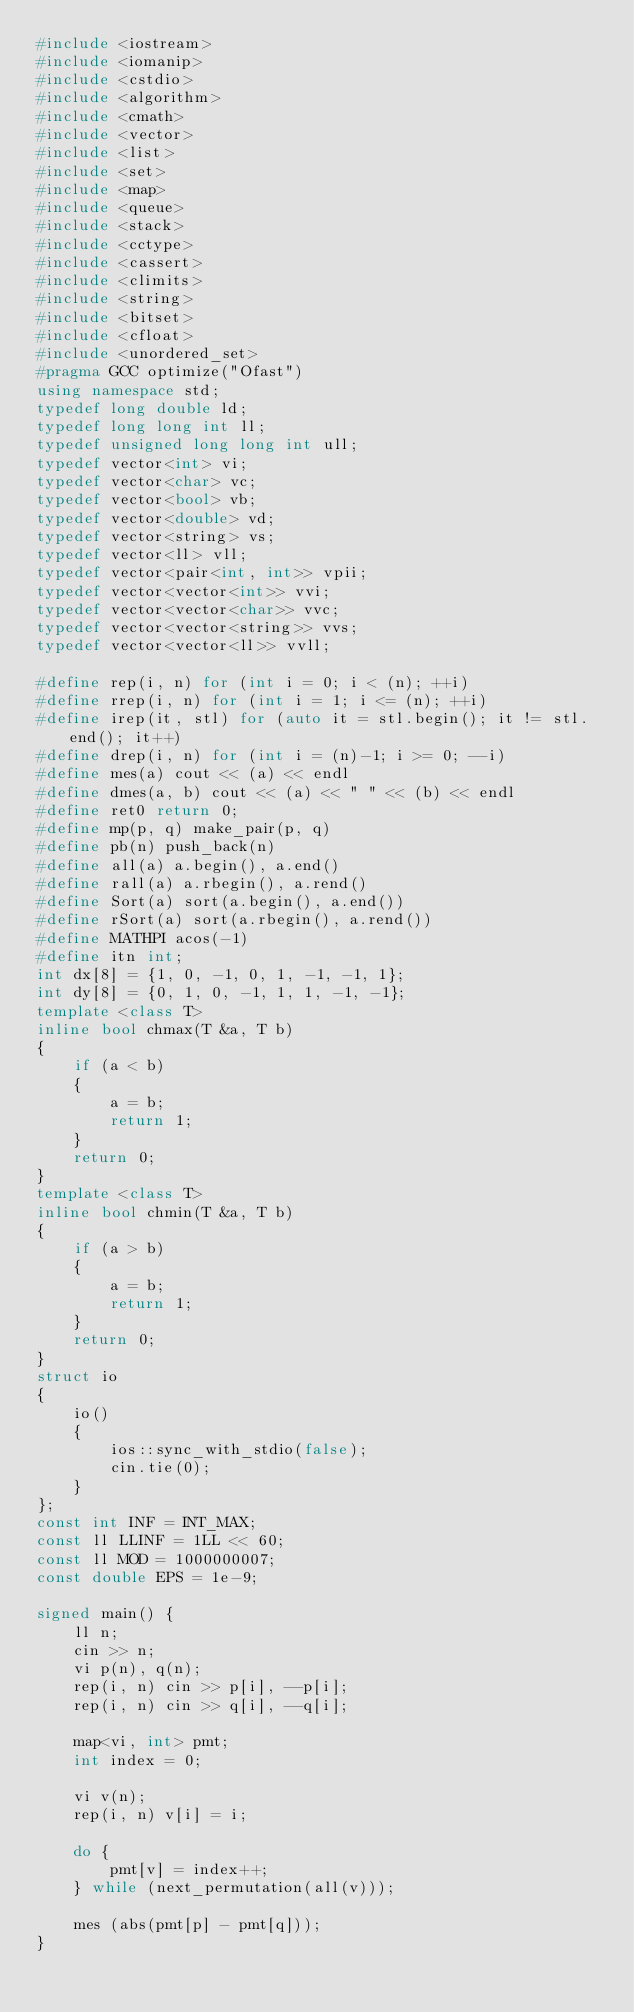Convert code to text. <code><loc_0><loc_0><loc_500><loc_500><_C++_>#include <iostream>
#include <iomanip>
#include <cstdio>
#include <algorithm>
#include <cmath>
#include <vector>
#include <list>
#include <set>
#include <map>
#include <queue>
#include <stack>
#include <cctype>
#include <cassert>
#include <climits>
#include <string>
#include <bitset>
#include <cfloat>
#include <unordered_set>
#pragma GCC optimize("Ofast")
using namespace std;
typedef long double ld;
typedef long long int ll;
typedef unsigned long long int ull;
typedef vector<int> vi;
typedef vector<char> vc;
typedef vector<bool> vb;
typedef vector<double> vd;
typedef vector<string> vs;
typedef vector<ll> vll;
typedef vector<pair<int, int>> vpii;
typedef vector<vector<int>> vvi;
typedef vector<vector<char>> vvc;
typedef vector<vector<string>> vvs;
typedef vector<vector<ll>> vvll;

#define rep(i, n) for (int i = 0; i < (n); ++i)
#define rrep(i, n) for (int i = 1; i <= (n); ++i)
#define irep(it, stl) for (auto it = stl.begin(); it != stl.end(); it++)
#define drep(i, n) for (int i = (n)-1; i >= 0; --i)
#define mes(a) cout << (a) << endl
#define dmes(a, b) cout << (a) << " " << (b) << endl
#define ret0 return 0;
#define mp(p, q) make_pair(p, q)
#define pb(n) push_back(n)
#define all(a) a.begin(), a.end()
#define rall(a) a.rbegin(), a.rend()
#define Sort(a) sort(a.begin(), a.end())
#define rSort(a) sort(a.rbegin(), a.rend())
#define MATHPI acos(-1)
#define itn int;
int dx[8] = {1, 0, -1, 0, 1, -1, -1, 1};
int dy[8] = {0, 1, 0, -1, 1, 1, -1, -1};
template <class T>
inline bool chmax(T &a, T b)
{
    if (a < b)
    {
        a = b;
        return 1;
    }
    return 0;
}
template <class T>
inline bool chmin(T &a, T b)
{
    if (a > b)
    {
        a = b;
        return 1;
    }
    return 0;
}
struct io
{
    io()
    {
        ios::sync_with_stdio(false);
        cin.tie(0);
    }
};
const int INF = INT_MAX;
const ll LLINF = 1LL << 60;
const ll MOD = 1000000007;
const double EPS = 1e-9;

signed main() {
    ll n;
    cin >> n;
    vi p(n), q(n);
    rep(i, n) cin >> p[i], --p[i];
    rep(i, n) cin >> q[i], --q[i];

    map<vi, int> pmt;
    int index = 0;

    vi v(n);
    rep(i, n) v[i] = i;

    do {
        pmt[v] = index++;
    } while (next_permutation(all(v)));

    mes (abs(pmt[p] - pmt[q]));
}
</code> 